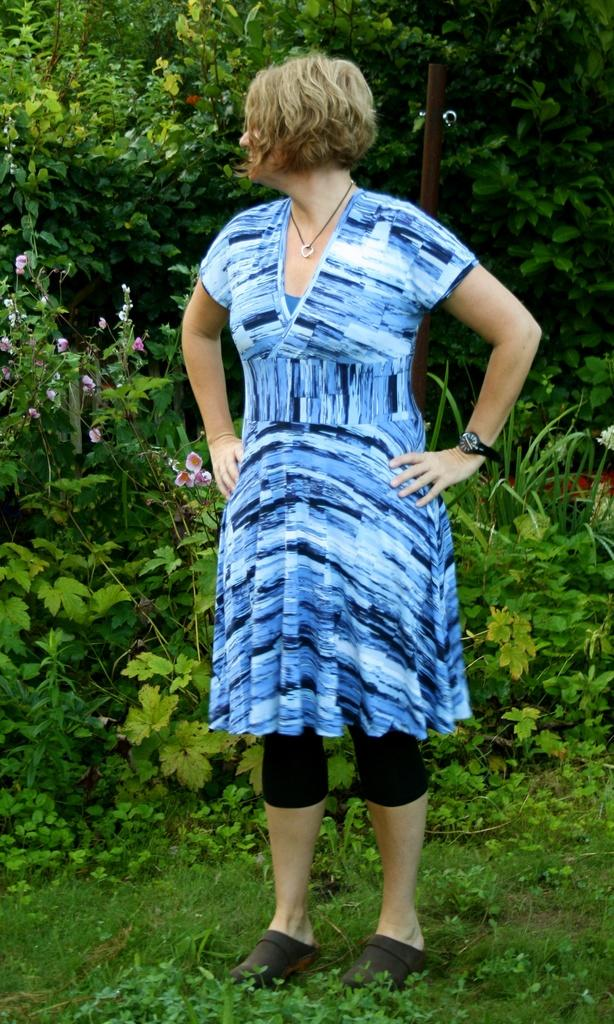What types of vegetation can be seen in the foreground of the picture? There are plants, flowers, and grass in the foreground of the picture. What is the woman in the foreground wearing? The woman in the foreground is wearing a blue dress. What can be seen in the background of the picture? There are trees and plants in the background of the picture. How many sisters are present in the image? There is no mention of sisters in the image, so it cannot be determined from the provided facts. What type of car can be seen in the image? There is no car present in the image. 